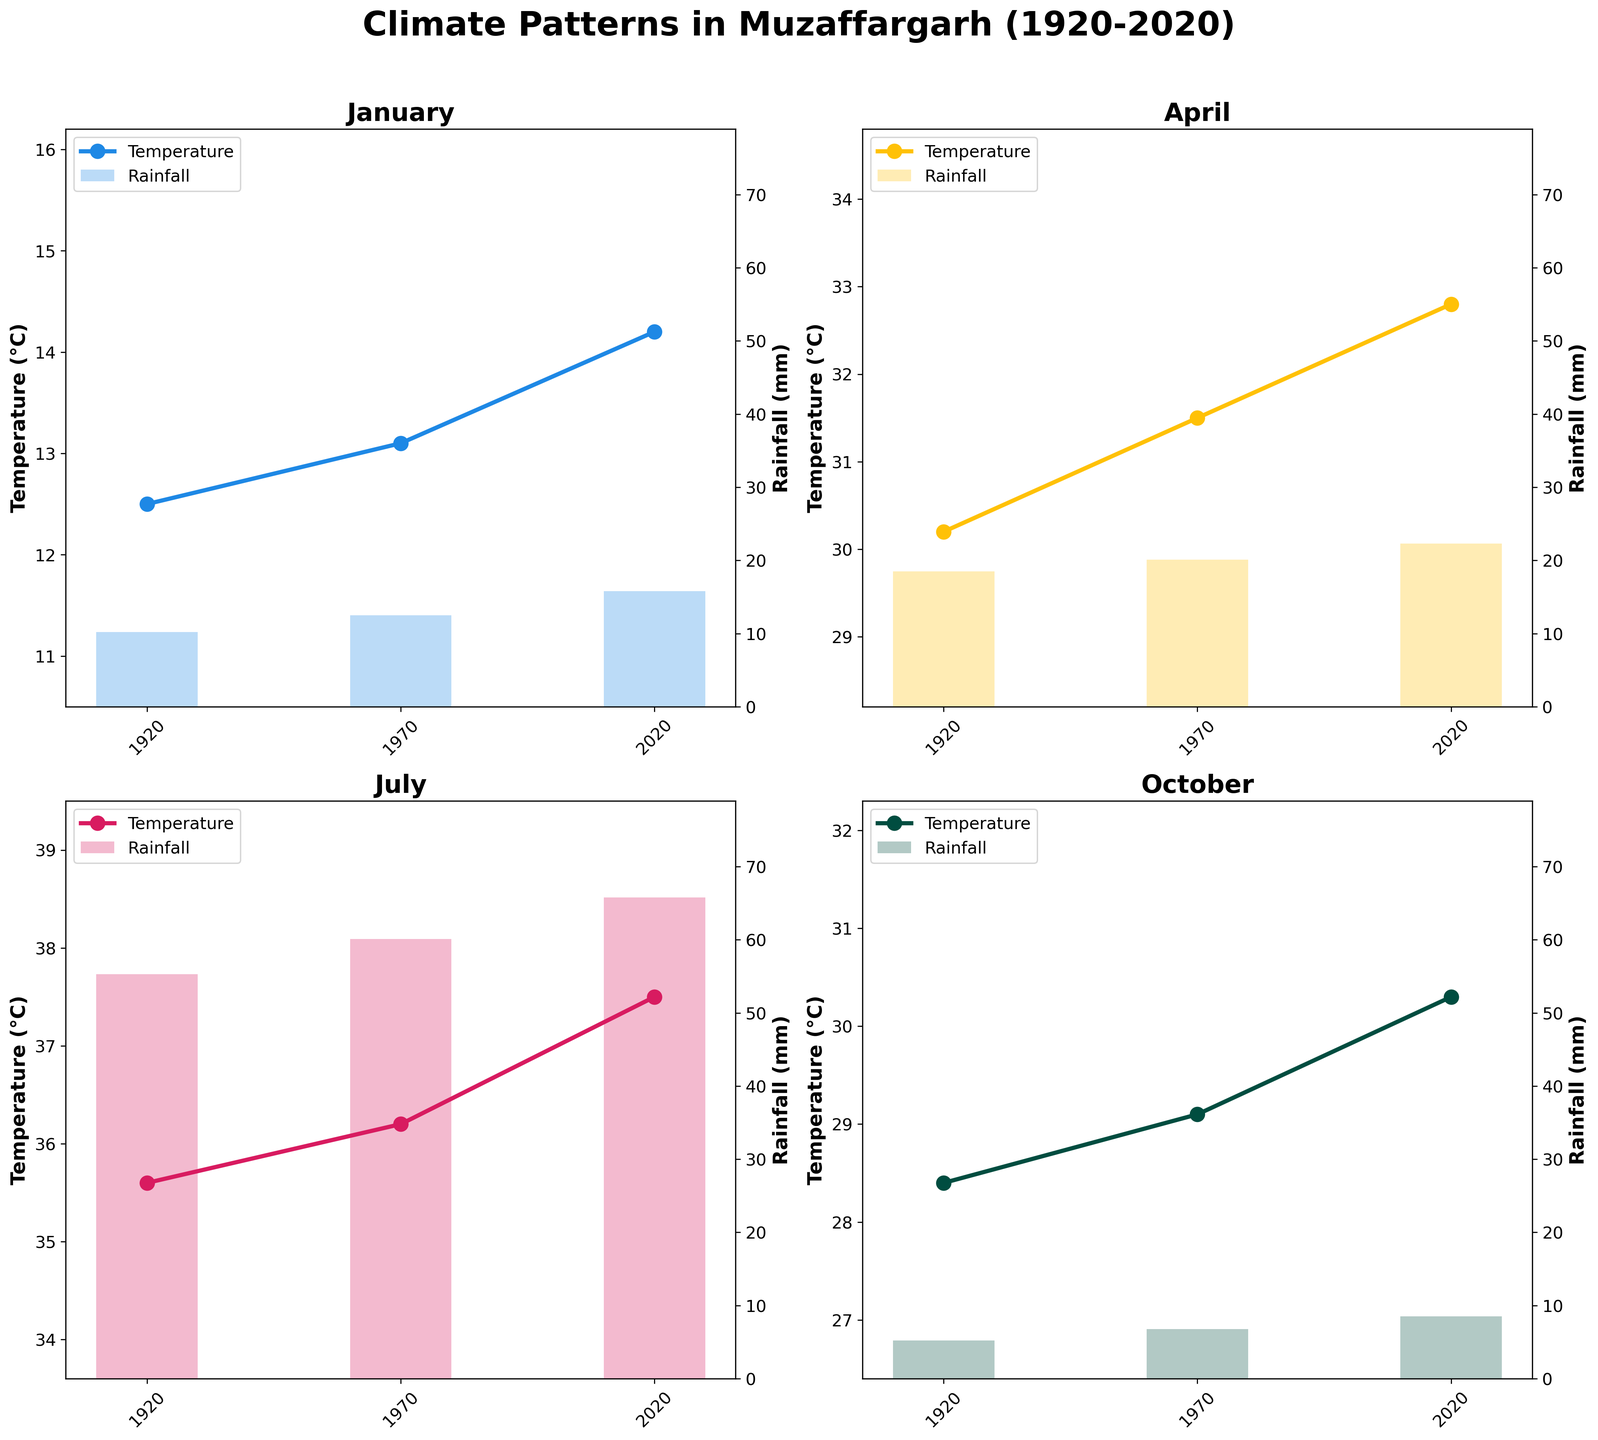What is the title of the figure? The title of the figure is displayed at the top and reads "Climate Patterns in Muzaffargarh (1920-2020)".
Answer: Climate Patterns in Muzaffargarh (1920-2020) What are the four months shown in the subplots? The four months can be seen as the title of each subplot within the grid: January, April, July, and October.
Answer: January, April, July, October In which month and year is the highest average temperature recorded? By examining the plots, the highest average temperature is recorded in July 2020 with a temperature of 37.5°C.
Answer: July 2020 How much rainfall was recorded in April 1970? Looking at the April subplot, the rainfall bar for 1970 shows a measurement of 20.1 mm.
Answer: 20.1 mm What’s the general trend in average temperature from 1920 to 2020 for January? Observing the January subplot, the average temperature increases from 12.5°C in 1920 to 14.2°C in 2020. Therefore, the trend is an increasing temperature over the century.
Answer: Increasing Which month has the least variation in rainfall over the years? By comparing the heights of the rainfall bars across all months, October shows the least variation with relatively lower and stable bars between 5.2 mm and 8.5 mm.
Answer: October How has the average temperature in July changed between 1920 and 2020? In the July subplot, the temperature values from 1920, 1970, and 2020 are compared showing an increase from 35.6°C (1920) to 37.5°C (2020), indicating a warming trend.
Answer: Increased Which year had the highest rainfall for any month and how much was it? By inspecting the tallest rainfall bar in any subplot, July 2020 had the highest rainfall, amounting to 65.8 mm.
Answer: July 2020, 65.8 mm Compare the rainfall in January 1920 and 1970. What is the difference? Looking at the bars for January, the rainfall in 1920 is 10.2 mm while in 1970 it is 12.5 mm. The difference is 12.5 mm - 10.2 mm = 2.3 mm.
Answer: 2.3 mm 